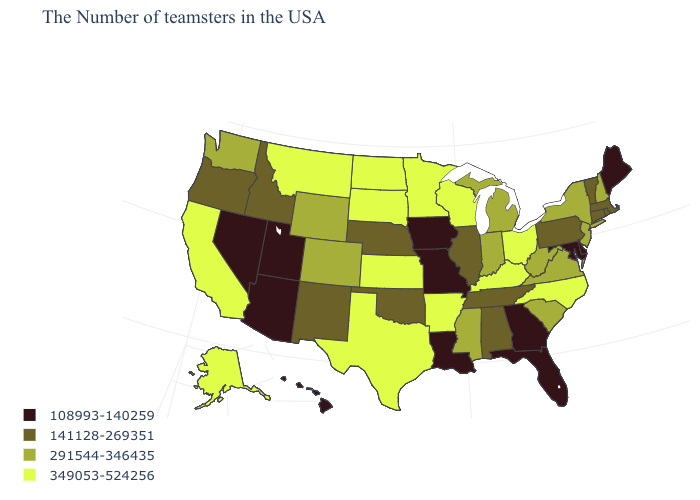Among the states that border New Hampshire , which have the highest value?
Keep it brief. Massachusetts, Vermont. What is the value of California?
Short answer required. 349053-524256. Does Indiana have the highest value in the MidWest?
Answer briefly. No. Does the first symbol in the legend represent the smallest category?
Be succinct. Yes. Does the first symbol in the legend represent the smallest category?
Answer briefly. Yes. What is the lowest value in the Northeast?
Answer briefly. 108993-140259. Which states have the lowest value in the USA?
Keep it brief. Maine, Delaware, Maryland, Florida, Georgia, Louisiana, Missouri, Iowa, Utah, Arizona, Nevada, Hawaii. Among the states that border Wisconsin , does Michigan have the highest value?
Keep it brief. No. Which states have the lowest value in the Northeast?
Keep it brief. Maine. What is the value of Rhode Island?
Give a very brief answer. 141128-269351. Name the states that have a value in the range 141128-269351?
Write a very short answer. Massachusetts, Rhode Island, Vermont, Connecticut, Pennsylvania, Alabama, Tennessee, Illinois, Nebraska, Oklahoma, New Mexico, Idaho, Oregon. What is the value of Indiana?
Short answer required. 291544-346435. Which states have the highest value in the USA?
Be succinct. North Carolina, Ohio, Kentucky, Wisconsin, Arkansas, Minnesota, Kansas, Texas, South Dakota, North Dakota, Montana, California, Alaska. What is the value of Indiana?
Answer briefly. 291544-346435. 